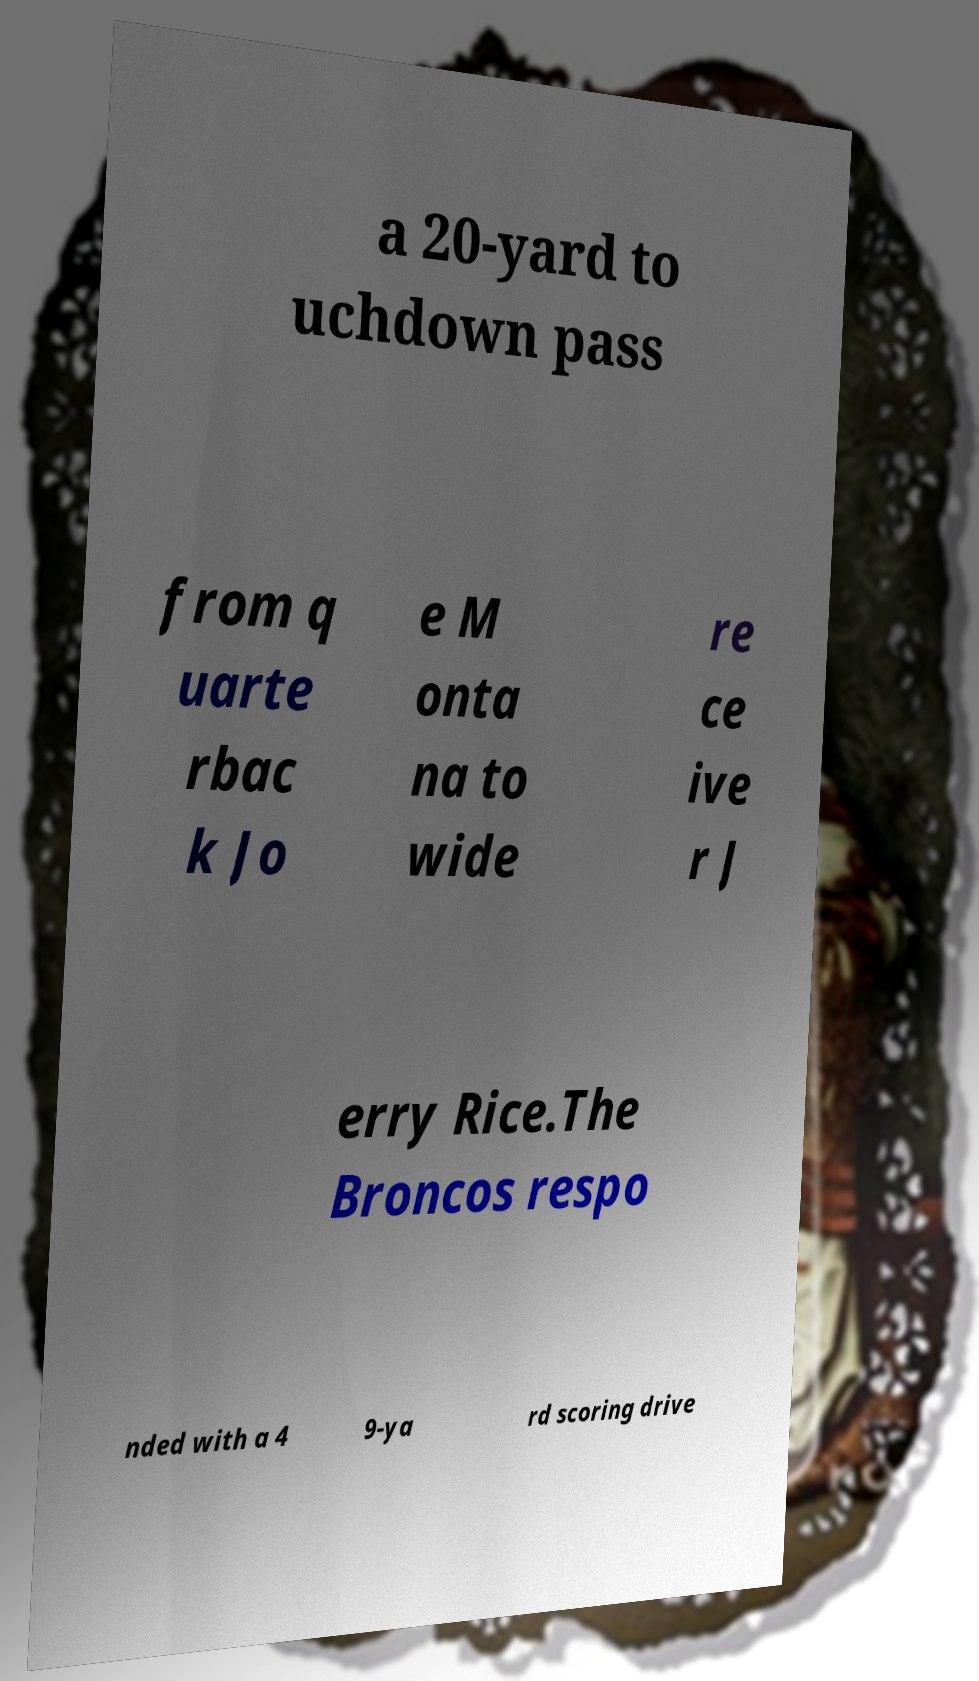Can you accurately transcribe the text from the provided image for me? a 20-yard to uchdown pass from q uarte rbac k Jo e M onta na to wide re ce ive r J erry Rice.The Broncos respo nded with a 4 9-ya rd scoring drive 